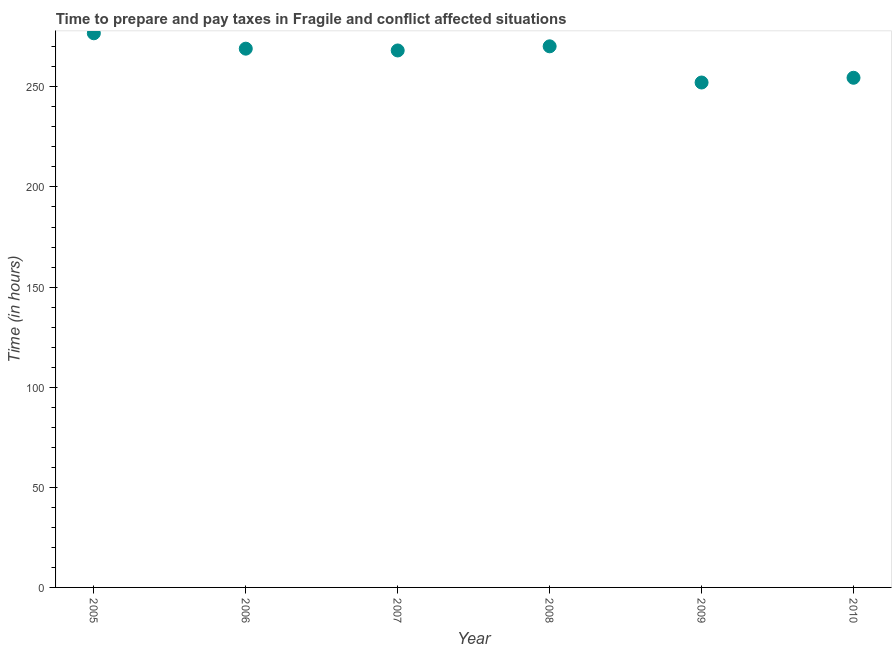What is the time to prepare and pay taxes in 2006?
Your response must be concise. 269.07. Across all years, what is the maximum time to prepare and pay taxes?
Keep it short and to the point. 276.75. Across all years, what is the minimum time to prepare and pay taxes?
Give a very brief answer. 252.17. In which year was the time to prepare and pay taxes minimum?
Your answer should be very brief. 2009. What is the sum of the time to prepare and pay taxes?
Ensure brevity in your answer.  1590.93. What is the difference between the time to prepare and pay taxes in 2006 and 2008?
Give a very brief answer. -1.17. What is the average time to prepare and pay taxes per year?
Make the answer very short. 265.16. What is the median time to prepare and pay taxes?
Your answer should be very brief. 268.62. In how many years, is the time to prepare and pay taxes greater than 90 hours?
Your answer should be compact. 6. Do a majority of the years between 2009 and 2007 (inclusive) have time to prepare and pay taxes greater than 160 hours?
Make the answer very short. No. What is the ratio of the time to prepare and pay taxes in 2009 to that in 2010?
Ensure brevity in your answer.  0.99. What is the difference between the highest and the second highest time to prepare and pay taxes?
Your answer should be very brief. 6.51. What is the difference between the highest and the lowest time to prepare and pay taxes?
Give a very brief answer. 24.58. In how many years, is the time to prepare and pay taxes greater than the average time to prepare and pay taxes taken over all years?
Keep it short and to the point. 4. What is the difference between two consecutive major ticks on the Y-axis?
Provide a short and direct response. 50. Does the graph contain any zero values?
Make the answer very short. No. Does the graph contain grids?
Provide a short and direct response. No. What is the title of the graph?
Provide a succinct answer. Time to prepare and pay taxes in Fragile and conflict affected situations. What is the label or title of the X-axis?
Give a very brief answer. Year. What is the label or title of the Y-axis?
Keep it short and to the point. Time (in hours). What is the Time (in hours) in 2005?
Provide a succinct answer. 276.75. What is the Time (in hours) in 2006?
Your answer should be very brief. 269.07. What is the Time (in hours) in 2007?
Your answer should be compact. 268.17. What is the Time (in hours) in 2008?
Your answer should be compact. 270.24. What is the Time (in hours) in 2009?
Offer a very short reply. 252.17. What is the Time (in hours) in 2010?
Offer a terse response. 254.53. What is the difference between the Time (in hours) in 2005 and 2006?
Your response must be concise. 7.68. What is the difference between the Time (in hours) in 2005 and 2007?
Provide a succinct answer. 8.58. What is the difference between the Time (in hours) in 2005 and 2008?
Give a very brief answer. 6.51. What is the difference between the Time (in hours) in 2005 and 2009?
Offer a very short reply. 24.58. What is the difference between the Time (in hours) in 2005 and 2010?
Provide a succinct answer. 22.22. What is the difference between the Time (in hours) in 2006 and 2007?
Provide a short and direct response. 0.9. What is the difference between the Time (in hours) in 2006 and 2008?
Make the answer very short. -1.17. What is the difference between the Time (in hours) in 2006 and 2009?
Your answer should be very brief. 16.9. What is the difference between the Time (in hours) in 2006 and 2010?
Ensure brevity in your answer.  14.54. What is the difference between the Time (in hours) in 2007 and 2008?
Offer a terse response. -2.07. What is the difference between the Time (in hours) in 2007 and 2009?
Give a very brief answer. 16.01. What is the difference between the Time (in hours) in 2007 and 2010?
Your response must be concise. 13.64. What is the difference between the Time (in hours) in 2008 and 2009?
Your answer should be compact. 18.07. What is the difference between the Time (in hours) in 2008 and 2010?
Make the answer very short. 15.71. What is the difference between the Time (in hours) in 2009 and 2010?
Your answer should be compact. -2.37. What is the ratio of the Time (in hours) in 2005 to that in 2006?
Offer a terse response. 1.03. What is the ratio of the Time (in hours) in 2005 to that in 2007?
Your response must be concise. 1.03. What is the ratio of the Time (in hours) in 2005 to that in 2009?
Your answer should be compact. 1.1. What is the ratio of the Time (in hours) in 2005 to that in 2010?
Your response must be concise. 1.09. What is the ratio of the Time (in hours) in 2006 to that in 2007?
Make the answer very short. 1. What is the ratio of the Time (in hours) in 2006 to that in 2008?
Provide a short and direct response. 1. What is the ratio of the Time (in hours) in 2006 to that in 2009?
Provide a short and direct response. 1.07. What is the ratio of the Time (in hours) in 2006 to that in 2010?
Make the answer very short. 1.06. What is the ratio of the Time (in hours) in 2007 to that in 2009?
Ensure brevity in your answer.  1.06. What is the ratio of the Time (in hours) in 2007 to that in 2010?
Provide a succinct answer. 1.05. What is the ratio of the Time (in hours) in 2008 to that in 2009?
Your response must be concise. 1.07. What is the ratio of the Time (in hours) in 2008 to that in 2010?
Your response must be concise. 1.06. 